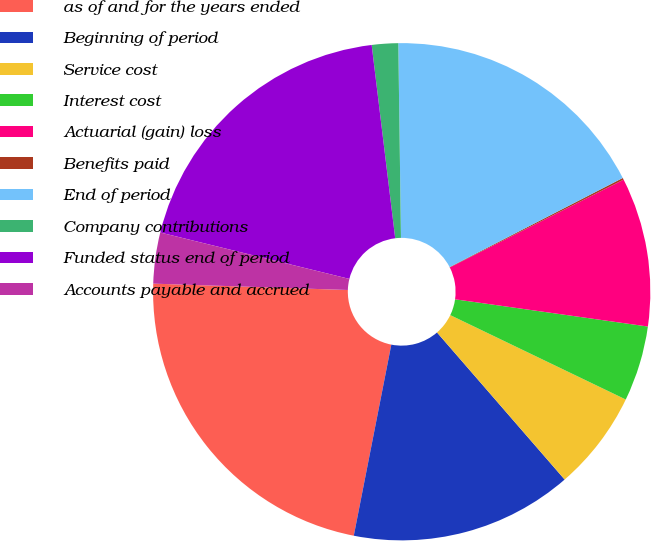Convert chart. <chart><loc_0><loc_0><loc_500><loc_500><pie_chart><fcel>as of and for the years ended<fcel>Beginning of period<fcel>Service cost<fcel>Interest cost<fcel>Actuarial (gain) loss<fcel>Benefits paid<fcel>End of period<fcel>Company contributions<fcel>Funded status end of period<fcel>Accounts payable and accrued<nl><fcel>22.43%<fcel>14.46%<fcel>6.49%<fcel>4.9%<fcel>9.68%<fcel>0.12%<fcel>17.65%<fcel>1.71%<fcel>19.24%<fcel>3.31%<nl></chart> 